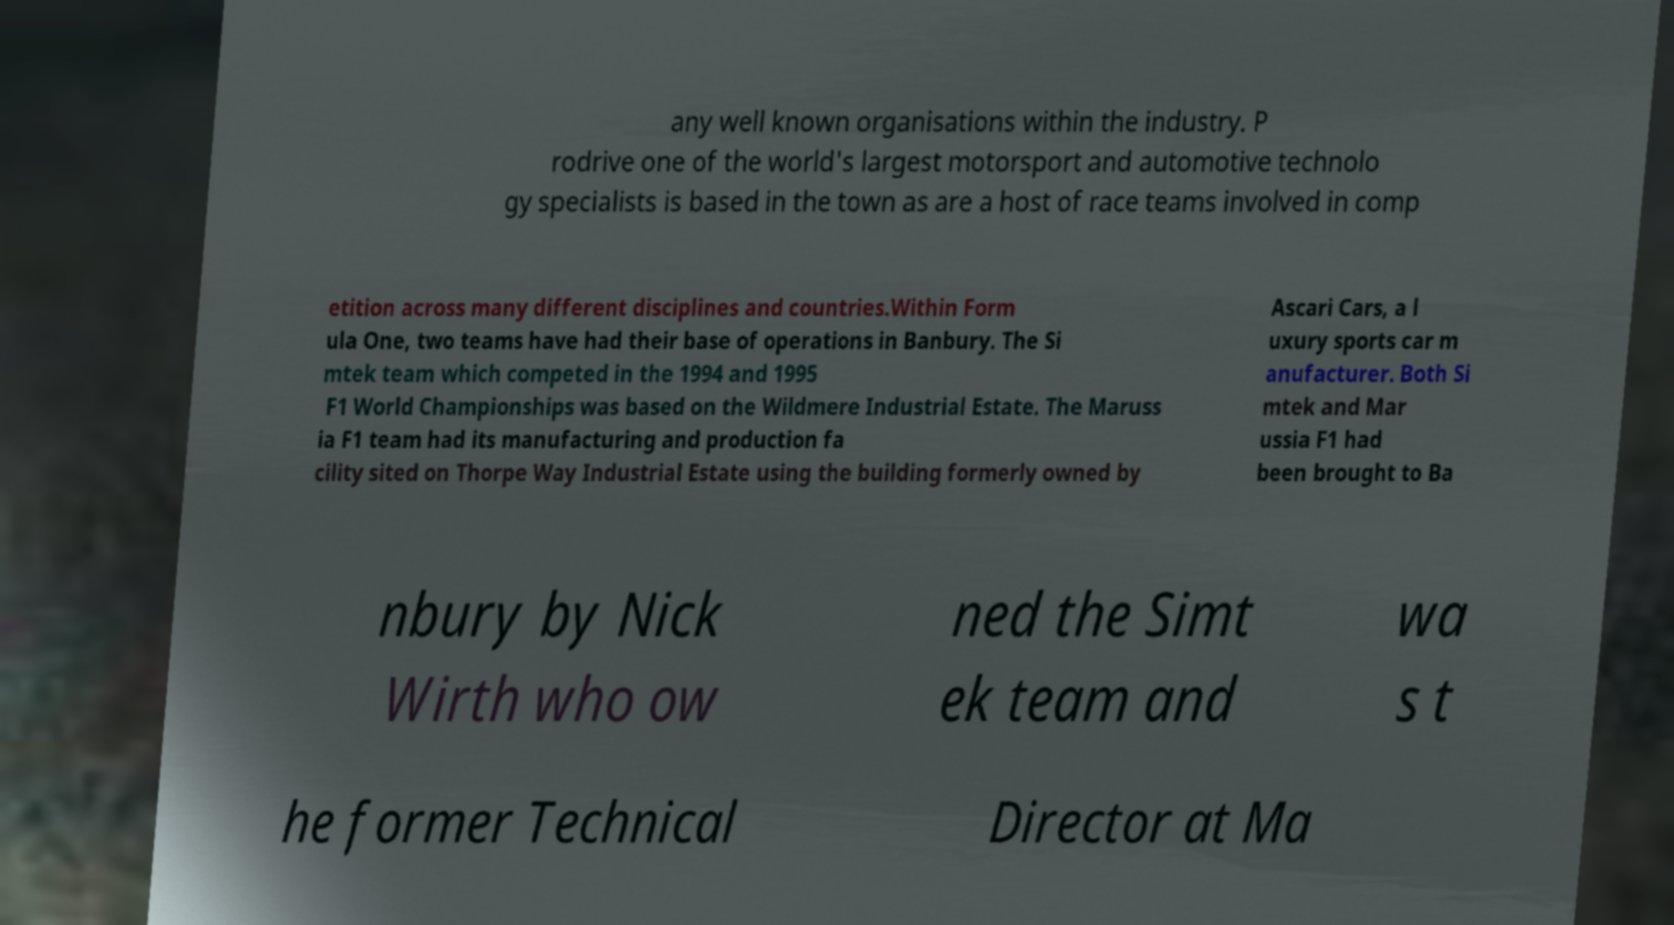What messages or text are displayed in this image? I need them in a readable, typed format. any well known organisations within the industry. P rodrive one of the world's largest motorsport and automotive technolo gy specialists is based in the town as are a host of race teams involved in comp etition across many different disciplines and countries.Within Form ula One, two teams have had their base of operations in Banbury. The Si mtek team which competed in the 1994 and 1995 F1 World Championships was based on the Wildmere Industrial Estate. The Maruss ia F1 team had its manufacturing and production fa cility sited on Thorpe Way Industrial Estate using the building formerly owned by Ascari Cars, a l uxury sports car m anufacturer. Both Si mtek and Mar ussia F1 had been brought to Ba nbury by Nick Wirth who ow ned the Simt ek team and wa s t he former Technical Director at Ma 